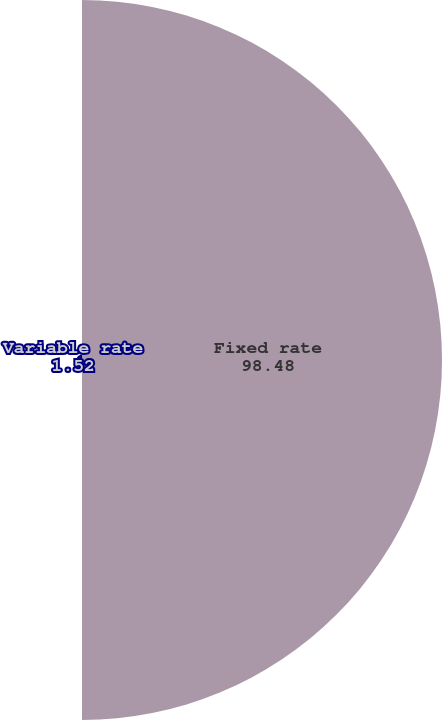<chart> <loc_0><loc_0><loc_500><loc_500><pie_chart><fcel>Fixed rate<fcel>Variable rate<nl><fcel>98.48%<fcel>1.52%<nl></chart> 